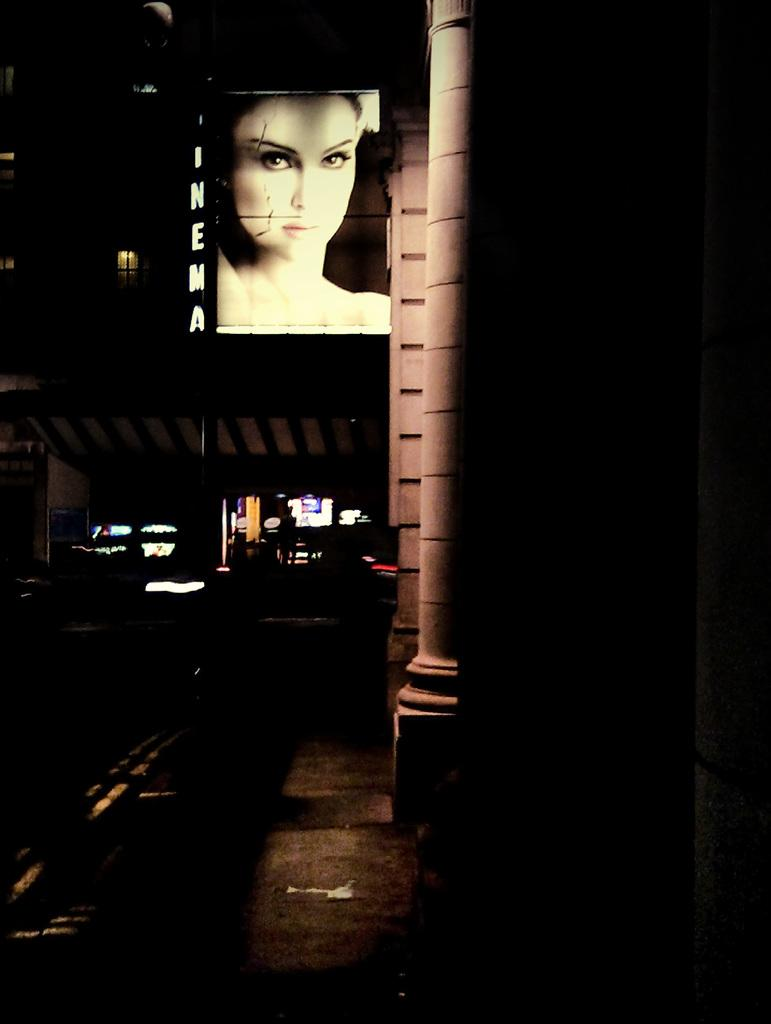What is the time of day depicted in the image? The image is taken during night mode. What architectural features can be seen in the image? There are pillars in the image. What is attached to one of the pillars? There is a woman hoarding attached to a pillar. What can be seen in the background of the image? There are buildings in the background of the image. What type of fruit is being offered as a reward in the image? There is no fruit or reward present in the image. Is there a church visible in the image? There is no church visible in the image; it features pillars and buildings in the background. 